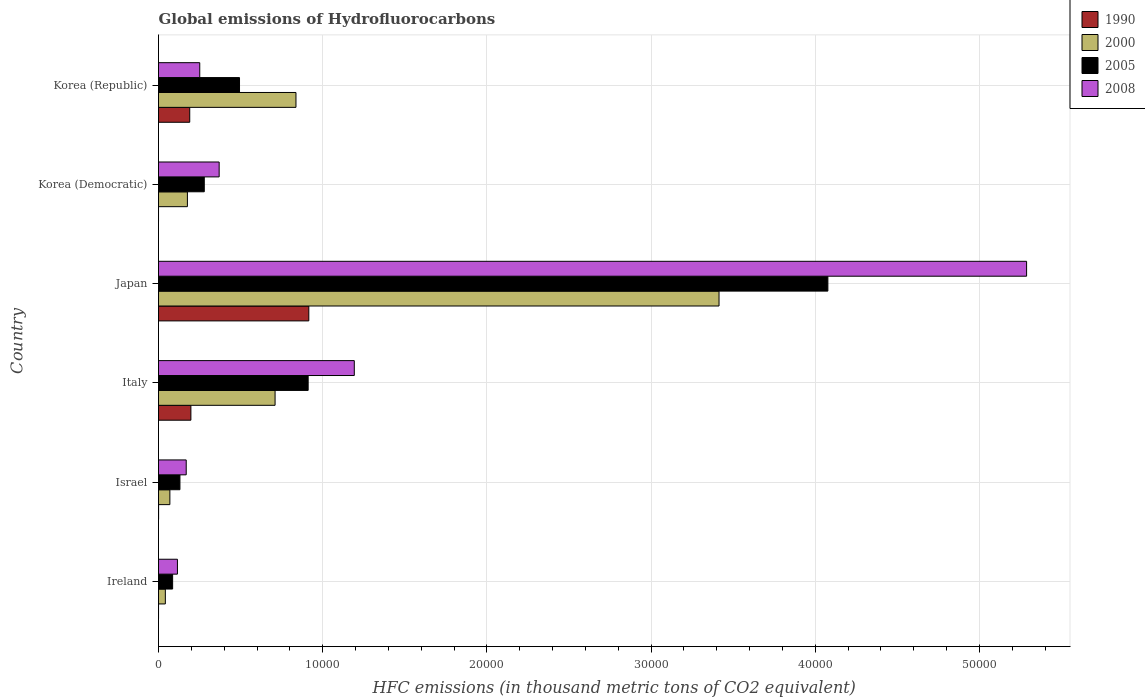How many groups of bars are there?
Provide a succinct answer. 6. Are the number of bars per tick equal to the number of legend labels?
Give a very brief answer. Yes. How many bars are there on the 3rd tick from the top?
Keep it short and to the point. 4. What is the label of the 2nd group of bars from the top?
Keep it short and to the point. Korea (Democratic). What is the global emissions of Hydrofluorocarbons in 2005 in Korea (Democratic)?
Keep it short and to the point. 2787.1. Across all countries, what is the maximum global emissions of Hydrofluorocarbons in 2005?
Your response must be concise. 4.08e+04. Across all countries, what is the minimum global emissions of Hydrofluorocarbons in 2008?
Your response must be concise. 1152.6. In which country was the global emissions of Hydrofluorocarbons in 2005 minimum?
Your answer should be compact. Ireland. What is the total global emissions of Hydrofluorocarbons in 1990 in the graph?
Offer a terse response. 1.30e+04. What is the difference between the global emissions of Hydrofluorocarbons in 2005 in Italy and that in Japan?
Your answer should be compact. -3.17e+04. What is the difference between the global emissions of Hydrofluorocarbons in 2000 in Ireland and the global emissions of Hydrofluorocarbons in 2005 in Italy?
Your answer should be compact. -8698.2. What is the average global emissions of Hydrofluorocarbons in 2000 per country?
Your answer should be compact. 8746.58. What is the difference between the global emissions of Hydrofluorocarbons in 1990 and global emissions of Hydrofluorocarbons in 2008 in Japan?
Your answer should be compact. -4.37e+04. In how many countries, is the global emissions of Hydrofluorocarbons in 1990 greater than 38000 thousand metric tons?
Keep it short and to the point. 0. What is the ratio of the global emissions of Hydrofluorocarbons in 2005 in Ireland to that in Korea (Republic)?
Give a very brief answer. 0.17. What is the difference between the highest and the second highest global emissions of Hydrofluorocarbons in 2008?
Your answer should be very brief. 4.09e+04. What is the difference between the highest and the lowest global emissions of Hydrofluorocarbons in 2000?
Your answer should be very brief. 3.37e+04. Is the sum of the global emissions of Hydrofluorocarbons in 2005 in Ireland and Italy greater than the maximum global emissions of Hydrofluorocarbons in 1990 across all countries?
Offer a very short reply. Yes. Is it the case that in every country, the sum of the global emissions of Hydrofluorocarbons in 2008 and global emissions of Hydrofluorocarbons in 1990 is greater than the global emissions of Hydrofluorocarbons in 2005?
Offer a very short reply. No. How many bars are there?
Make the answer very short. 24. Are all the bars in the graph horizontal?
Offer a very short reply. Yes. Does the graph contain any zero values?
Offer a terse response. No. Where does the legend appear in the graph?
Offer a very short reply. Top right. How many legend labels are there?
Make the answer very short. 4. What is the title of the graph?
Offer a terse response. Global emissions of Hydrofluorocarbons. Does "1993" appear as one of the legend labels in the graph?
Your answer should be very brief. No. What is the label or title of the X-axis?
Provide a succinct answer. HFC emissions (in thousand metric tons of CO2 equivalent). What is the HFC emissions (in thousand metric tons of CO2 equivalent) of 1990 in Ireland?
Ensure brevity in your answer.  1.2. What is the HFC emissions (in thousand metric tons of CO2 equivalent) of 2000 in Ireland?
Provide a succinct answer. 416.3. What is the HFC emissions (in thousand metric tons of CO2 equivalent) of 2005 in Ireland?
Ensure brevity in your answer.  859.7. What is the HFC emissions (in thousand metric tons of CO2 equivalent) in 2008 in Ireland?
Provide a short and direct response. 1152.6. What is the HFC emissions (in thousand metric tons of CO2 equivalent) in 2000 in Israel?
Give a very brief answer. 691.9. What is the HFC emissions (in thousand metric tons of CO2 equivalent) in 2005 in Israel?
Your answer should be very brief. 1305. What is the HFC emissions (in thousand metric tons of CO2 equivalent) of 2008 in Israel?
Provide a short and direct response. 1687.8. What is the HFC emissions (in thousand metric tons of CO2 equivalent) in 1990 in Italy?
Provide a short and direct response. 1972.2. What is the HFC emissions (in thousand metric tons of CO2 equivalent) in 2000 in Italy?
Keep it short and to the point. 7099.5. What is the HFC emissions (in thousand metric tons of CO2 equivalent) of 2005 in Italy?
Offer a very short reply. 9114.5. What is the HFC emissions (in thousand metric tons of CO2 equivalent) of 2008 in Italy?
Provide a short and direct response. 1.19e+04. What is the HFC emissions (in thousand metric tons of CO2 equivalent) in 1990 in Japan?
Provide a short and direct response. 9154.3. What is the HFC emissions (in thousand metric tons of CO2 equivalent) of 2000 in Japan?
Your answer should be compact. 3.41e+04. What is the HFC emissions (in thousand metric tons of CO2 equivalent) of 2005 in Japan?
Make the answer very short. 4.08e+04. What is the HFC emissions (in thousand metric tons of CO2 equivalent) in 2008 in Japan?
Your answer should be very brief. 5.29e+04. What is the HFC emissions (in thousand metric tons of CO2 equivalent) in 1990 in Korea (Democratic)?
Offer a very short reply. 0.2. What is the HFC emissions (in thousand metric tons of CO2 equivalent) of 2000 in Korea (Democratic)?
Your response must be concise. 1760.1. What is the HFC emissions (in thousand metric tons of CO2 equivalent) of 2005 in Korea (Democratic)?
Provide a succinct answer. 2787.1. What is the HFC emissions (in thousand metric tons of CO2 equivalent) of 2008 in Korea (Democratic)?
Keep it short and to the point. 3693.8. What is the HFC emissions (in thousand metric tons of CO2 equivalent) of 1990 in Korea (Republic)?
Give a very brief answer. 1901.7. What is the HFC emissions (in thousand metric tons of CO2 equivalent) of 2000 in Korea (Republic)?
Your answer should be very brief. 8371.9. What is the HFC emissions (in thousand metric tons of CO2 equivalent) of 2005 in Korea (Republic)?
Your response must be concise. 4933.9. What is the HFC emissions (in thousand metric tons of CO2 equivalent) in 2008 in Korea (Republic)?
Provide a short and direct response. 2511.2. Across all countries, what is the maximum HFC emissions (in thousand metric tons of CO2 equivalent) in 1990?
Keep it short and to the point. 9154.3. Across all countries, what is the maximum HFC emissions (in thousand metric tons of CO2 equivalent) in 2000?
Provide a succinct answer. 3.41e+04. Across all countries, what is the maximum HFC emissions (in thousand metric tons of CO2 equivalent) of 2005?
Ensure brevity in your answer.  4.08e+04. Across all countries, what is the maximum HFC emissions (in thousand metric tons of CO2 equivalent) of 2008?
Keep it short and to the point. 5.29e+04. Across all countries, what is the minimum HFC emissions (in thousand metric tons of CO2 equivalent) of 2000?
Provide a succinct answer. 416.3. Across all countries, what is the minimum HFC emissions (in thousand metric tons of CO2 equivalent) of 2005?
Ensure brevity in your answer.  859.7. Across all countries, what is the minimum HFC emissions (in thousand metric tons of CO2 equivalent) of 2008?
Provide a succinct answer. 1152.6. What is the total HFC emissions (in thousand metric tons of CO2 equivalent) of 1990 in the graph?
Ensure brevity in your answer.  1.30e+04. What is the total HFC emissions (in thousand metric tons of CO2 equivalent) in 2000 in the graph?
Your answer should be compact. 5.25e+04. What is the total HFC emissions (in thousand metric tons of CO2 equivalent) of 2005 in the graph?
Provide a succinct answer. 5.98e+04. What is the total HFC emissions (in thousand metric tons of CO2 equivalent) in 2008 in the graph?
Offer a very short reply. 7.38e+04. What is the difference between the HFC emissions (in thousand metric tons of CO2 equivalent) of 2000 in Ireland and that in Israel?
Make the answer very short. -275.6. What is the difference between the HFC emissions (in thousand metric tons of CO2 equivalent) of 2005 in Ireland and that in Israel?
Your answer should be very brief. -445.3. What is the difference between the HFC emissions (in thousand metric tons of CO2 equivalent) of 2008 in Ireland and that in Israel?
Make the answer very short. -535.2. What is the difference between the HFC emissions (in thousand metric tons of CO2 equivalent) of 1990 in Ireland and that in Italy?
Provide a short and direct response. -1971. What is the difference between the HFC emissions (in thousand metric tons of CO2 equivalent) of 2000 in Ireland and that in Italy?
Your answer should be very brief. -6683.2. What is the difference between the HFC emissions (in thousand metric tons of CO2 equivalent) in 2005 in Ireland and that in Italy?
Your response must be concise. -8254.8. What is the difference between the HFC emissions (in thousand metric tons of CO2 equivalent) in 2008 in Ireland and that in Italy?
Offer a terse response. -1.08e+04. What is the difference between the HFC emissions (in thousand metric tons of CO2 equivalent) in 1990 in Ireland and that in Japan?
Your response must be concise. -9153.1. What is the difference between the HFC emissions (in thousand metric tons of CO2 equivalent) in 2000 in Ireland and that in Japan?
Your response must be concise. -3.37e+04. What is the difference between the HFC emissions (in thousand metric tons of CO2 equivalent) in 2005 in Ireland and that in Japan?
Keep it short and to the point. -3.99e+04. What is the difference between the HFC emissions (in thousand metric tons of CO2 equivalent) in 2008 in Ireland and that in Japan?
Give a very brief answer. -5.17e+04. What is the difference between the HFC emissions (in thousand metric tons of CO2 equivalent) of 2000 in Ireland and that in Korea (Democratic)?
Your answer should be very brief. -1343.8. What is the difference between the HFC emissions (in thousand metric tons of CO2 equivalent) of 2005 in Ireland and that in Korea (Democratic)?
Provide a succinct answer. -1927.4. What is the difference between the HFC emissions (in thousand metric tons of CO2 equivalent) of 2008 in Ireland and that in Korea (Democratic)?
Keep it short and to the point. -2541.2. What is the difference between the HFC emissions (in thousand metric tons of CO2 equivalent) in 1990 in Ireland and that in Korea (Republic)?
Ensure brevity in your answer.  -1900.5. What is the difference between the HFC emissions (in thousand metric tons of CO2 equivalent) in 2000 in Ireland and that in Korea (Republic)?
Your response must be concise. -7955.6. What is the difference between the HFC emissions (in thousand metric tons of CO2 equivalent) in 2005 in Ireland and that in Korea (Republic)?
Your answer should be compact. -4074.2. What is the difference between the HFC emissions (in thousand metric tons of CO2 equivalent) in 2008 in Ireland and that in Korea (Republic)?
Give a very brief answer. -1358.6. What is the difference between the HFC emissions (in thousand metric tons of CO2 equivalent) of 1990 in Israel and that in Italy?
Offer a very short reply. -1967.6. What is the difference between the HFC emissions (in thousand metric tons of CO2 equivalent) in 2000 in Israel and that in Italy?
Give a very brief answer. -6407.6. What is the difference between the HFC emissions (in thousand metric tons of CO2 equivalent) of 2005 in Israel and that in Italy?
Keep it short and to the point. -7809.5. What is the difference between the HFC emissions (in thousand metric tons of CO2 equivalent) of 2008 in Israel and that in Italy?
Keep it short and to the point. -1.02e+04. What is the difference between the HFC emissions (in thousand metric tons of CO2 equivalent) of 1990 in Israel and that in Japan?
Your answer should be compact. -9149.7. What is the difference between the HFC emissions (in thousand metric tons of CO2 equivalent) of 2000 in Israel and that in Japan?
Your answer should be very brief. -3.34e+04. What is the difference between the HFC emissions (in thousand metric tons of CO2 equivalent) of 2005 in Israel and that in Japan?
Give a very brief answer. -3.95e+04. What is the difference between the HFC emissions (in thousand metric tons of CO2 equivalent) of 2008 in Israel and that in Japan?
Keep it short and to the point. -5.12e+04. What is the difference between the HFC emissions (in thousand metric tons of CO2 equivalent) in 2000 in Israel and that in Korea (Democratic)?
Your answer should be very brief. -1068.2. What is the difference between the HFC emissions (in thousand metric tons of CO2 equivalent) of 2005 in Israel and that in Korea (Democratic)?
Keep it short and to the point. -1482.1. What is the difference between the HFC emissions (in thousand metric tons of CO2 equivalent) of 2008 in Israel and that in Korea (Democratic)?
Make the answer very short. -2006. What is the difference between the HFC emissions (in thousand metric tons of CO2 equivalent) of 1990 in Israel and that in Korea (Republic)?
Your answer should be compact. -1897.1. What is the difference between the HFC emissions (in thousand metric tons of CO2 equivalent) of 2000 in Israel and that in Korea (Republic)?
Offer a very short reply. -7680. What is the difference between the HFC emissions (in thousand metric tons of CO2 equivalent) in 2005 in Israel and that in Korea (Republic)?
Give a very brief answer. -3628.9. What is the difference between the HFC emissions (in thousand metric tons of CO2 equivalent) in 2008 in Israel and that in Korea (Republic)?
Your answer should be very brief. -823.4. What is the difference between the HFC emissions (in thousand metric tons of CO2 equivalent) in 1990 in Italy and that in Japan?
Provide a short and direct response. -7182.1. What is the difference between the HFC emissions (in thousand metric tons of CO2 equivalent) in 2000 in Italy and that in Japan?
Provide a short and direct response. -2.70e+04. What is the difference between the HFC emissions (in thousand metric tons of CO2 equivalent) in 2005 in Italy and that in Japan?
Ensure brevity in your answer.  -3.17e+04. What is the difference between the HFC emissions (in thousand metric tons of CO2 equivalent) in 2008 in Italy and that in Japan?
Offer a terse response. -4.09e+04. What is the difference between the HFC emissions (in thousand metric tons of CO2 equivalent) in 1990 in Italy and that in Korea (Democratic)?
Provide a short and direct response. 1972. What is the difference between the HFC emissions (in thousand metric tons of CO2 equivalent) of 2000 in Italy and that in Korea (Democratic)?
Provide a short and direct response. 5339.4. What is the difference between the HFC emissions (in thousand metric tons of CO2 equivalent) of 2005 in Italy and that in Korea (Democratic)?
Your answer should be compact. 6327.4. What is the difference between the HFC emissions (in thousand metric tons of CO2 equivalent) of 2008 in Italy and that in Korea (Democratic)?
Offer a very short reply. 8230.7. What is the difference between the HFC emissions (in thousand metric tons of CO2 equivalent) in 1990 in Italy and that in Korea (Republic)?
Keep it short and to the point. 70.5. What is the difference between the HFC emissions (in thousand metric tons of CO2 equivalent) in 2000 in Italy and that in Korea (Republic)?
Your response must be concise. -1272.4. What is the difference between the HFC emissions (in thousand metric tons of CO2 equivalent) in 2005 in Italy and that in Korea (Republic)?
Offer a very short reply. 4180.6. What is the difference between the HFC emissions (in thousand metric tons of CO2 equivalent) in 2008 in Italy and that in Korea (Republic)?
Your answer should be compact. 9413.3. What is the difference between the HFC emissions (in thousand metric tons of CO2 equivalent) in 1990 in Japan and that in Korea (Democratic)?
Provide a short and direct response. 9154.1. What is the difference between the HFC emissions (in thousand metric tons of CO2 equivalent) in 2000 in Japan and that in Korea (Democratic)?
Give a very brief answer. 3.24e+04. What is the difference between the HFC emissions (in thousand metric tons of CO2 equivalent) in 2005 in Japan and that in Korea (Democratic)?
Offer a terse response. 3.80e+04. What is the difference between the HFC emissions (in thousand metric tons of CO2 equivalent) in 2008 in Japan and that in Korea (Democratic)?
Ensure brevity in your answer.  4.92e+04. What is the difference between the HFC emissions (in thousand metric tons of CO2 equivalent) of 1990 in Japan and that in Korea (Republic)?
Your answer should be very brief. 7252.6. What is the difference between the HFC emissions (in thousand metric tons of CO2 equivalent) of 2000 in Japan and that in Korea (Republic)?
Your response must be concise. 2.58e+04. What is the difference between the HFC emissions (in thousand metric tons of CO2 equivalent) in 2005 in Japan and that in Korea (Republic)?
Provide a succinct answer. 3.58e+04. What is the difference between the HFC emissions (in thousand metric tons of CO2 equivalent) in 2008 in Japan and that in Korea (Republic)?
Provide a succinct answer. 5.04e+04. What is the difference between the HFC emissions (in thousand metric tons of CO2 equivalent) in 1990 in Korea (Democratic) and that in Korea (Republic)?
Provide a short and direct response. -1901.5. What is the difference between the HFC emissions (in thousand metric tons of CO2 equivalent) of 2000 in Korea (Democratic) and that in Korea (Republic)?
Keep it short and to the point. -6611.8. What is the difference between the HFC emissions (in thousand metric tons of CO2 equivalent) in 2005 in Korea (Democratic) and that in Korea (Republic)?
Ensure brevity in your answer.  -2146.8. What is the difference between the HFC emissions (in thousand metric tons of CO2 equivalent) of 2008 in Korea (Democratic) and that in Korea (Republic)?
Offer a terse response. 1182.6. What is the difference between the HFC emissions (in thousand metric tons of CO2 equivalent) in 1990 in Ireland and the HFC emissions (in thousand metric tons of CO2 equivalent) in 2000 in Israel?
Offer a terse response. -690.7. What is the difference between the HFC emissions (in thousand metric tons of CO2 equivalent) in 1990 in Ireland and the HFC emissions (in thousand metric tons of CO2 equivalent) in 2005 in Israel?
Offer a very short reply. -1303.8. What is the difference between the HFC emissions (in thousand metric tons of CO2 equivalent) in 1990 in Ireland and the HFC emissions (in thousand metric tons of CO2 equivalent) in 2008 in Israel?
Your answer should be compact. -1686.6. What is the difference between the HFC emissions (in thousand metric tons of CO2 equivalent) of 2000 in Ireland and the HFC emissions (in thousand metric tons of CO2 equivalent) of 2005 in Israel?
Make the answer very short. -888.7. What is the difference between the HFC emissions (in thousand metric tons of CO2 equivalent) in 2000 in Ireland and the HFC emissions (in thousand metric tons of CO2 equivalent) in 2008 in Israel?
Keep it short and to the point. -1271.5. What is the difference between the HFC emissions (in thousand metric tons of CO2 equivalent) of 2005 in Ireland and the HFC emissions (in thousand metric tons of CO2 equivalent) of 2008 in Israel?
Your answer should be compact. -828.1. What is the difference between the HFC emissions (in thousand metric tons of CO2 equivalent) of 1990 in Ireland and the HFC emissions (in thousand metric tons of CO2 equivalent) of 2000 in Italy?
Provide a short and direct response. -7098.3. What is the difference between the HFC emissions (in thousand metric tons of CO2 equivalent) of 1990 in Ireland and the HFC emissions (in thousand metric tons of CO2 equivalent) of 2005 in Italy?
Give a very brief answer. -9113.3. What is the difference between the HFC emissions (in thousand metric tons of CO2 equivalent) in 1990 in Ireland and the HFC emissions (in thousand metric tons of CO2 equivalent) in 2008 in Italy?
Provide a succinct answer. -1.19e+04. What is the difference between the HFC emissions (in thousand metric tons of CO2 equivalent) of 2000 in Ireland and the HFC emissions (in thousand metric tons of CO2 equivalent) of 2005 in Italy?
Your answer should be compact. -8698.2. What is the difference between the HFC emissions (in thousand metric tons of CO2 equivalent) in 2000 in Ireland and the HFC emissions (in thousand metric tons of CO2 equivalent) in 2008 in Italy?
Provide a succinct answer. -1.15e+04. What is the difference between the HFC emissions (in thousand metric tons of CO2 equivalent) of 2005 in Ireland and the HFC emissions (in thousand metric tons of CO2 equivalent) of 2008 in Italy?
Make the answer very short. -1.11e+04. What is the difference between the HFC emissions (in thousand metric tons of CO2 equivalent) of 1990 in Ireland and the HFC emissions (in thousand metric tons of CO2 equivalent) of 2000 in Japan?
Your answer should be very brief. -3.41e+04. What is the difference between the HFC emissions (in thousand metric tons of CO2 equivalent) in 1990 in Ireland and the HFC emissions (in thousand metric tons of CO2 equivalent) in 2005 in Japan?
Keep it short and to the point. -4.08e+04. What is the difference between the HFC emissions (in thousand metric tons of CO2 equivalent) of 1990 in Ireland and the HFC emissions (in thousand metric tons of CO2 equivalent) of 2008 in Japan?
Make the answer very short. -5.29e+04. What is the difference between the HFC emissions (in thousand metric tons of CO2 equivalent) in 2000 in Ireland and the HFC emissions (in thousand metric tons of CO2 equivalent) in 2005 in Japan?
Provide a short and direct response. -4.04e+04. What is the difference between the HFC emissions (in thousand metric tons of CO2 equivalent) of 2000 in Ireland and the HFC emissions (in thousand metric tons of CO2 equivalent) of 2008 in Japan?
Give a very brief answer. -5.25e+04. What is the difference between the HFC emissions (in thousand metric tons of CO2 equivalent) of 2005 in Ireland and the HFC emissions (in thousand metric tons of CO2 equivalent) of 2008 in Japan?
Your response must be concise. -5.20e+04. What is the difference between the HFC emissions (in thousand metric tons of CO2 equivalent) in 1990 in Ireland and the HFC emissions (in thousand metric tons of CO2 equivalent) in 2000 in Korea (Democratic)?
Keep it short and to the point. -1758.9. What is the difference between the HFC emissions (in thousand metric tons of CO2 equivalent) of 1990 in Ireland and the HFC emissions (in thousand metric tons of CO2 equivalent) of 2005 in Korea (Democratic)?
Make the answer very short. -2785.9. What is the difference between the HFC emissions (in thousand metric tons of CO2 equivalent) in 1990 in Ireland and the HFC emissions (in thousand metric tons of CO2 equivalent) in 2008 in Korea (Democratic)?
Make the answer very short. -3692.6. What is the difference between the HFC emissions (in thousand metric tons of CO2 equivalent) of 2000 in Ireland and the HFC emissions (in thousand metric tons of CO2 equivalent) of 2005 in Korea (Democratic)?
Your response must be concise. -2370.8. What is the difference between the HFC emissions (in thousand metric tons of CO2 equivalent) in 2000 in Ireland and the HFC emissions (in thousand metric tons of CO2 equivalent) in 2008 in Korea (Democratic)?
Keep it short and to the point. -3277.5. What is the difference between the HFC emissions (in thousand metric tons of CO2 equivalent) of 2005 in Ireland and the HFC emissions (in thousand metric tons of CO2 equivalent) of 2008 in Korea (Democratic)?
Ensure brevity in your answer.  -2834.1. What is the difference between the HFC emissions (in thousand metric tons of CO2 equivalent) in 1990 in Ireland and the HFC emissions (in thousand metric tons of CO2 equivalent) in 2000 in Korea (Republic)?
Your answer should be very brief. -8370.7. What is the difference between the HFC emissions (in thousand metric tons of CO2 equivalent) of 1990 in Ireland and the HFC emissions (in thousand metric tons of CO2 equivalent) of 2005 in Korea (Republic)?
Your answer should be compact. -4932.7. What is the difference between the HFC emissions (in thousand metric tons of CO2 equivalent) in 1990 in Ireland and the HFC emissions (in thousand metric tons of CO2 equivalent) in 2008 in Korea (Republic)?
Your answer should be compact. -2510. What is the difference between the HFC emissions (in thousand metric tons of CO2 equivalent) in 2000 in Ireland and the HFC emissions (in thousand metric tons of CO2 equivalent) in 2005 in Korea (Republic)?
Your answer should be very brief. -4517.6. What is the difference between the HFC emissions (in thousand metric tons of CO2 equivalent) in 2000 in Ireland and the HFC emissions (in thousand metric tons of CO2 equivalent) in 2008 in Korea (Republic)?
Ensure brevity in your answer.  -2094.9. What is the difference between the HFC emissions (in thousand metric tons of CO2 equivalent) in 2005 in Ireland and the HFC emissions (in thousand metric tons of CO2 equivalent) in 2008 in Korea (Republic)?
Give a very brief answer. -1651.5. What is the difference between the HFC emissions (in thousand metric tons of CO2 equivalent) of 1990 in Israel and the HFC emissions (in thousand metric tons of CO2 equivalent) of 2000 in Italy?
Provide a short and direct response. -7094.9. What is the difference between the HFC emissions (in thousand metric tons of CO2 equivalent) in 1990 in Israel and the HFC emissions (in thousand metric tons of CO2 equivalent) in 2005 in Italy?
Offer a terse response. -9109.9. What is the difference between the HFC emissions (in thousand metric tons of CO2 equivalent) in 1990 in Israel and the HFC emissions (in thousand metric tons of CO2 equivalent) in 2008 in Italy?
Your answer should be compact. -1.19e+04. What is the difference between the HFC emissions (in thousand metric tons of CO2 equivalent) of 2000 in Israel and the HFC emissions (in thousand metric tons of CO2 equivalent) of 2005 in Italy?
Keep it short and to the point. -8422.6. What is the difference between the HFC emissions (in thousand metric tons of CO2 equivalent) of 2000 in Israel and the HFC emissions (in thousand metric tons of CO2 equivalent) of 2008 in Italy?
Offer a terse response. -1.12e+04. What is the difference between the HFC emissions (in thousand metric tons of CO2 equivalent) in 2005 in Israel and the HFC emissions (in thousand metric tons of CO2 equivalent) in 2008 in Italy?
Give a very brief answer. -1.06e+04. What is the difference between the HFC emissions (in thousand metric tons of CO2 equivalent) in 1990 in Israel and the HFC emissions (in thousand metric tons of CO2 equivalent) in 2000 in Japan?
Provide a succinct answer. -3.41e+04. What is the difference between the HFC emissions (in thousand metric tons of CO2 equivalent) of 1990 in Israel and the HFC emissions (in thousand metric tons of CO2 equivalent) of 2005 in Japan?
Ensure brevity in your answer.  -4.08e+04. What is the difference between the HFC emissions (in thousand metric tons of CO2 equivalent) of 1990 in Israel and the HFC emissions (in thousand metric tons of CO2 equivalent) of 2008 in Japan?
Make the answer very short. -5.29e+04. What is the difference between the HFC emissions (in thousand metric tons of CO2 equivalent) of 2000 in Israel and the HFC emissions (in thousand metric tons of CO2 equivalent) of 2005 in Japan?
Your response must be concise. -4.01e+04. What is the difference between the HFC emissions (in thousand metric tons of CO2 equivalent) of 2000 in Israel and the HFC emissions (in thousand metric tons of CO2 equivalent) of 2008 in Japan?
Give a very brief answer. -5.22e+04. What is the difference between the HFC emissions (in thousand metric tons of CO2 equivalent) in 2005 in Israel and the HFC emissions (in thousand metric tons of CO2 equivalent) in 2008 in Japan?
Your answer should be compact. -5.16e+04. What is the difference between the HFC emissions (in thousand metric tons of CO2 equivalent) of 1990 in Israel and the HFC emissions (in thousand metric tons of CO2 equivalent) of 2000 in Korea (Democratic)?
Ensure brevity in your answer.  -1755.5. What is the difference between the HFC emissions (in thousand metric tons of CO2 equivalent) in 1990 in Israel and the HFC emissions (in thousand metric tons of CO2 equivalent) in 2005 in Korea (Democratic)?
Your answer should be very brief. -2782.5. What is the difference between the HFC emissions (in thousand metric tons of CO2 equivalent) in 1990 in Israel and the HFC emissions (in thousand metric tons of CO2 equivalent) in 2008 in Korea (Democratic)?
Ensure brevity in your answer.  -3689.2. What is the difference between the HFC emissions (in thousand metric tons of CO2 equivalent) of 2000 in Israel and the HFC emissions (in thousand metric tons of CO2 equivalent) of 2005 in Korea (Democratic)?
Give a very brief answer. -2095.2. What is the difference between the HFC emissions (in thousand metric tons of CO2 equivalent) in 2000 in Israel and the HFC emissions (in thousand metric tons of CO2 equivalent) in 2008 in Korea (Democratic)?
Your answer should be very brief. -3001.9. What is the difference between the HFC emissions (in thousand metric tons of CO2 equivalent) of 2005 in Israel and the HFC emissions (in thousand metric tons of CO2 equivalent) of 2008 in Korea (Democratic)?
Provide a short and direct response. -2388.8. What is the difference between the HFC emissions (in thousand metric tons of CO2 equivalent) in 1990 in Israel and the HFC emissions (in thousand metric tons of CO2 equivalent) in 2000 in Korea (Republic)?
Your response must be concise. -8367.3. What is the difference between the HFC emissions (in thousand metric tons of CO2 equivalent) in 1990 in Israel and the HFC emissions (in thousand metric tons of CO2 equivalent) in 2005 in Korea (Republic)?
Offer a terse response. -4929.3. What is the difference between the HFC emissions (in thousand metric tons of CO2 equivalent) of 1990 in Israel and the HFC emissions (in thousand metric tons of CO2 equivalent) of 2008 in Korea (Republic)?
Ensure brevity in your answer.  -2506.6. What is the difference between the HFC emissions (in thousand metric tons of CO2 equivalent) in 2000 in Israel and the HFC emissions (in thousand metric tons of CO2 equivalent) in 2005 in Korea (Republic)?
Offer a terse response. -4242. What is the difference between the HFC emissions (in thousand metric tons of CO2 equivalent) in 2000 in Israel and the HFC emissions (in thousand metric tons of CO2 equivalent) in 2008 in Korea (Republic)?
Your answer should be very brief. -1819.3. What is the difference between the HFC emissions (in thousand metric tons of CO2 equivalent) of 2005 in Israel and the HFC emissions (in thousand metric tons of CO2 equivalent) of 2008 in Korea (Republic)?
Offer a very short reply. -1206.2. What is the difference between the HFC emissions (in thousand metric tons of CO2 equivalent) of 1990 in Italy and the HFC emissions (in thousand metric tons of CO2 equivalent) of 2000 in Japan?
Give a very brief answer. -3.22e+04. What is the difference between the HFC emissions (in thousand metric tons of CO2 equivalent) in 1990 in Italy and the HFC emissions (in thousand metric tons of CO2 equivalent) in 2005 in Japan?
Offer a very short reply. -3.88e+04. What is the difference between the HFC emissions (in thousand metric tons of CO2 equivalent) of 1990 in Italy and the HFC emissions (in thousand metric tons of CO2 equivalent) of 2008 in Japan?
Your answer should be very brief. -5.09e+04. What is the difference between the HFC emissions (in thousand metric tons of CO2 equivalent) in 2000 in Italy and the HFC emissions (in thousand metric tons of CO2 equivalent) in 2005 in Japan?
Keep it short and to the point. -3.37e+04. What is the difference between the HFC emissions (in thousand metric tons of CO2 equivalent) in 2000 in Italy and the HFC emissions (in thousand metric tons of CO2 equivalent) in 2008 in Japan?
Your answer should be very brief. -4.58e+04. What is the difference between the HFC emissions (in thousand metric tons of CO2 equivalent) in 2005 in Italy and the HFC emissions (in thousand metric tons of CO2 equivalent) in 2008 in Japan?
Make the answer very short. -4.38e+04. What is the difference between the HFC emissions (in thousand metric tons of CO2 equivalent) of 1990 in Italy and the HFC emissions (in thousand metric tons of CO2 equivalent) of 2000 in Korea (Democratic)?
Ensure brevity in your answer.  212.1. What is the difference between the HFC emissions (in thousand metric tons of CO2 equivalent) in 1990 in Italy and the HFC emissions (in thousand metric tons of CO2 equivalent) in 2005 in Korea (Democratic)?
Make the answer very short. -814.9. What is the difference between the HFC emissions (in thousand metric tons of CO2 equivalent) in 1990 in Italy and the HFC emissions (in thousand metric tons of CO2 equivalent) in 2008 in Korea (Democratic)?
Ensure brevity in your answer.  -1721.6. What is the difference between the HFC emissions (in thousand metric tons of CO2 equivalent) in 2000 in Italy and the HFC emissions (in thousand metric tons of CO2 equivalent) in 2005 in Korea (Democratic)?
Keep it short and to the point. 4312.4. What is the difference between the HFC emissions (in thousand metric tons of CO2 equivalent) of 2000 in Italy and the HFC emissions (in thousand metric tons of CO2 equivalent) of 2008 in Korea (Democratic)?
Keep it short and to the point. 3405.7. What is the difference between the HFC emissions (in thousand metric tons of CO2 equivalent) in 2005 in Italy and the HFC emissions (in thousand metric tons of CO2 equivalent) in 2008 in Korea (Democratic)?
Your answer should be very brief. 5420.7. What is the difference between the HFC emissions (in thousand metric tons of CO2 equivalent) of 1990 in Italy and the HFC emissions (in thousand metric tons of CO2 equivalent) of 2000 in Korea (Republic)?
Offer a very short reply. -6399.7. What is the difference between the HFC emissions (in thousand metric tons of CO2 equivalent) in 1990 in Italy and the HFC emissions (in thousand metric tons of CO2 equivalent) in 2005 in Korea (Republic)?
Ensure brevity in your answer.  -2961.7. What is the difference between the HFC emissions (in thousand metric tons of CO2 equivalent) in 1990 in Italy and the HFC emissions (in thousand metric tons of CO2 equivalent) in 2008 in Korea (Republic)?
Provide a succinct answer. -539. What is the difference between the HFC emissions (in thousand metric tons of CO2 equivalent) of 2000 in Italy and the HFC emissions (in thousand metric tons of CO2 equivalent) of 2005 in Korea (Republic)?
Your answer should be compact. 2165.6. What is the difference between the HFC emissions (in thousand metric tons of CO2 equivalent) in 2000 in Italy and the HFC emissions (in thousand metric tons of CO2 equivalent) in 2008 in Korea (Republic)?
Provide a short and direct response. 4588.3. What is the difference between the HFC emissions (in thousand metric tons of CO2 equivalent) of 2005 in Italy and the HFC emissions (in thousand metric tons of CO2 equivalent) of 2008 in Korea (Republic)?
Keep it short and to the point. 6603.3. What is the difference between the HFC emissions (in thousand metric tons of CO2 equivalent) in 1990 in Japan and the HFC emissions (in thousand metric tons of CO2 equivalent) in 2000 in Korea (Democratic)?
Give a very brief answer. 7394.2. What is the difference between the HFC emissions (in thousand metric tons of CO2 equivalent) in 1990 in Japan and the HFC emissions (in thousand metric tons of CO2 equivalent) in 2005 in Korea (Democratic)?
Your response must be concise. 6367.2. What is the difference between the HFC emissions (in thousand metric tons of CO2 equivalent) of 1990 in Japan and the HFC emissions (in thousand metric tons of CO2 equivalent) of 2008 in Korea (Democratic)?
Provide a short and direct response. 5460.5. What is the difference between the HFC emissions (in thousand metric tons of CO2 equivalent) of 2000 in Japan and the HFC emissions (in thousand metric tons of CO2 equivalent) of 2005 in Korea (Democratic)?
Give a very brief answer. 3.14e+04. What is the difference between the HFC emissions (in thousand metric tons of CO2 equivalent) of 2000 in Japan and the HFC emissions (in thousand metric tons of CO2 equivalent) of 2008 in Korea (Democratic)?
Offer a terse response. 3.04e+04. What is the difference between the HFC emissions (in thousand metric tons of CO2 equivalent) in 2005 in Japan and the HFC emissions (in thousand metric tons of CO2 equivalent) in 2008 in Korea (Democratic)?
Provide a succinct answer. 3.71e+04. What is the difference between the HFC emissions (in thousand metric tons of CO2 equivalent) of 1990 in Japan and the HFC emissions (in thousand metric tons of CO2 equivalent) of 2000 in Korea (Republic)?
Make the answer very short. 782.4. What is the difference between the HFC emissions (in thousand metric tons of CO2 equivalent) of 1990 in Japan and the HFC emissions (in thousand metric tons of CO2 equivalent) of 2005 in Korea (Republic)?
Your answer should be very brief. 4220.4. What is the difference between the HFC emissions (in thousand metric tons of CO2 equivalent) of 1990 in Japan and the HFC emissions (in thousand metric tons of CO2 equivalent) of 2008 in Korea (Republic)?
Offer a very short reply. 6643.1. What is the difference between the HFC emissions (in thousand metric tons of CO2 equivalent) in 2000 in Japan and the HFC emissions (in thousand metric tons of CO2 equivalent) in 2005 in Korea (Republic)?
Offer a very short reply. 2.92e+04. What is the difference between the HFC emissions (in thousand metric tons of CO2 equivalent) in 2000 in Japan and the HFC emissions (in thousand metric tons of CO2 equivalent) in 2008 in Korea (Republic)?
Provide a succinct answer. 3.16e+04. What is the difference between the HFC emissions (in thousand metric tons of CO2 equivalent) in 2005 in Japan and the HFC emissions (in thousand metric tons of CO2 equivalent) in 2008 in Korea (Republic)?
Your response must be concise. 3.83e+04. What is the difference between the HFC emissions (in thousand metric tons of CO2 equivalent) of 1990 in Korea (Democratic) and the HFC emissions (in thousand metric tons of CO2 equivalent) of 2000 in Korea (Republic)?
Provide a succinct answer. -8371.7. What is the difference between the HFC emissions (in thousand metric tons of CO2 equivalent) of 1990 in Korea (Democratic) and the HFC emissions (in thousand metric tons of CO2 equivalent) of 2005 in Korea (Republic)?
Keep it short and to the point. -4933.7. What is the difference between the HFC emissions (in thousand metric tons of CO2 equivalent) of 1990 in Korea (Democratic) and the HFC emissions (in thousand metric tons of CO2 equivalent) of 2008 in Korea (Republic)?
Keep it short and to the point. -2511. What is the difference between the HFC emissions (in thousand metric tons of CO2 equivalent) in 2000 in Korea (Democratic) and the HFC emissions (in thousand metric tons of CO2 equivalent) in 2005 in Korea (Republic)?
Give a very brief answer. -3173.8. What is the difference between the HFC emissions (in thousand metric tons of CO2 equivalent) in 2000 in Korea (Democratic) and the HFC emissions (in thousand metric tons of CO2 equivalent) in 2008 in Korea (Republic)?
Provide a short and direct response. -751.1. What is the difference between the HFC emissions (in thousand metric tons of CO2 equivalent) in 2005 in Korea (Democratic) and the HFC emissions (in thousand metric tons of CO2 equivalent) in 2008 in Korea (Republic)?
Ensure brevity in your answer.  275.9. What is the average HFC emissions (in thousand metric tons of CO2 equivalent) of 1990 per country?
Make the answer very short. 2172.37. What is the average HFC emissions (in thousand metric tons of CO2 equivalent) of 2000 per country?
Your answer should be compact. 8746.58. What is the average HFC emissions (in thousand metric tons of CO2 equivalent) in 2005 per country?
Ensure brevity in your answer.  9961.45. What is the average HFC emissions (in thousand metric tons of CO2 equivalent) of 2008 per country?
Give a very brief answer. 1.23e+04. What is the difference between the HFC emissions (in thousand metric tons of CO2 equivalent) of 1990 and HFC emissions (in thousand metric tons of CO2 equivalent) of 2000 in Ireland?
Your answer should be very brief. -415.1. What is the difference between the HFC emissions (in thousand metric tons of CO2 equivalent) of 1990 and HFC emissions (in thousand metric tons of CO2 equivalent) of 2005 in Ireland?
Provide a succinct answer. -858.5. What is the difference between the HFC emissions (in thousand metric tons of CO2 equivalent) in 1990 and HFC emissions (in thousand metric tons of CO2 equivalent) in 2008 in Ireland?
Offer a very short reply. -1151.4. What is the difference between the HFC emissions (in thousand metric tons of CO2 equivalent) in 2000 and HFC emissions (in thousand metric tons of CO2 equivalent) in 2005 in Ireland?
Provide a short and direct response. -443.4. What is the difference between the HFC emissions (in thousand metric tons of CO2 equivalent) of 2000 and HFC emissions (in thousand metric tons of CO2 equivalent) of 2008 in Ireland?
Ensure brevity in your answer.  -736.3. What is the difference between the HFC emissions (in thousand metric tons of CO2 equivalent) in 2005 and HFC emissions (in thousand metric tons of CO2 equivalent) in 2008 in Ireland?
Your response must be concise. -292.9. What is the difference between the HFC emissions (in thousand metric tons of CO2 equivalent) of 1990 and HFC emissions (in thousand metric tons of CO2 equivalent) of 2000 in Israel?
Offer a terse response. -687.3. What is the difference between the HFC emissions (in thousand metric tons of CO2 equivalent) in 1990 and HFC emissions (in thousand metric tons of CO2 equivalent) in 2005 in Israel?
Give a very brief answer. -1300.4. What is the difference between the HFC emissions (in thousand metric tons of CO2 equivalent) of 1990 and HFC emissions (in thousand metric tons of CO2 equivalent) of 2008 in Israel?
Keep it short and to the point. -1683.2. What is the difference between the HFC emissions (in thousand metric tons of CO2 equivalent) in 2000 and HFC emissions (in thousand metric tons of CO2 equivalent) in 2005 in Israel?
Provide a short and direct response. -613.1. What is the difference between the HFC emissions (in thousand metric tons of CO2 equivalent) in 2000 and HFC emissions (in thousand metric tons of CO2 equivalent) in 2008 in Israel?
Provide a short and direct response. -995.9. What is the difference between the HFC emissions (in thousand metric tons of CO2 equivalent) of 2005 and HFC emissions (in thousand metric tons of CO2 equivalent) of 2008 in Israel?
Your answer should be compact. -382.8. What is the difference between the HFC emissions (in thousand metric tons of CO2 equivalent) of 1990 and HFC emissions (in thousand metric tons of CO2 equivalent) of 2000 in Italy?
Offer a terse response. -5127.3. What is the difference between the HFC emissions (in thousand metric tons of CO2 equivalent) of 1990 and HFC emissions (in thousand metric tons of CO2 equivalent) of 2005 in Italy?
Give a very brief answer. -7142.3. What is the difference between the HFC emissions (in thousand metric tons of CO2 equivalent) of 1990 and HFC emissions (in thousand metric tons of CO2 equivalent) of 2008 in Italy?
Keep it short and to the point. -9952.3. What is the difference between the HFC emissions (in thousand metric tons of CO2 equivalent) of 2000 and HFC emissions (in thousand metric tons of CO2 equivalent) of 2005 in Italy?
Offer a very short reply. -2015. What is the difference between the HFC emissions (in thousand metric tons of CO2 equivalent) of 2000 and HFC emissions (in thousand metric tons of CO2 equivalent) of 2008 in Italy?
Provide a short and direct response. -4825. What is the difference between the HFC emissions (in thousand metric tons of CO2 equivalent) in 2005 and HFC emissions (in thousand metric tons of CO2 equivalent) in 2008 in Italy?
Ensure brevity in your answer.  -2810. What is the difference between the HFC emissions (in thousand metric tons of CO2 equivalent) in 1990 and HFC emissions (in thousand metric tons of CO2 equivalent) in 2000 in Japan?
Offer a very short reply. -2.50e+04. What is the difference between the HFC emissions (in thousand metric tons of CO2 equivalent) of 1990 and HFC emissions (in thousand metric tons of CO2 equivalent) of 2005 in Japan?
Ensure brevity in your answer.  -3.16e+04. What is the difference between the HFC emissions (in thousand metric tons of CO2 equivalent) of 1990 and HFC emissions (in thousand metric tons of CO2 equivalent) of 2008 in Japan?
Your response must be concise. -4.37e+04. What is the difference between the HFC emissions (in thousand metric tons of CO2 equivalent) of 2000 and HFC emissions (in thousand metric tons of CO2 equivalent) of 2005 in Japan?
Provide a short and direct response. -6628.7. What is the difference between the HFC emissions (in thousand metric tons of CO2 equivalent) in 2000 and HFC emissions (in thousand metric tons of CO2 equivalent) in 2008 in Japan?
Offer a terse response. -1.87e+04. What is the difference between the HFC emissions (in thousand metric tons of CO2 equivalent) of 2005 and HFC emissions (in thousand metric tons of CO2 equivalent) of 2008 in Japan?
Provide a short and direct response. -1.21e+04. What is the difference between the HFC emissions (in thousand metric tons of CO2 equivalent) of 1990 and HFC emissions (in thousand metric tons of CO2 equivalent) of 2000 in Korea (Democratic)?
Offer a terse response. -1759.9. What is the difference between the HFC emissions (in thousand metric tons of CO2 equivalent) in 1990 and HFC emissions (in thousand metric tons of CO2 equivalent) in 2005 in Korea (Democratic)?
Offer a terse response. -2786.9. What is the difference between the HFC emissions (in thousand metric tons of CO2 equivalent) of 1990 and HFC emissions (in thousand metric tons of CO2 equivalent) of 2008 in Korea (Democratic)?
Provide a short and direct response. -3693.6. What is the difference between the HFC emissions (in thousand metric tons of CO2 equivalent) in 2000 and HFC emissions (in thousand metric tons of CO2 equivalent) in 2005 in Korea (Democratic)?
Keep it short and to the point. -1027. What is the difference between the HFC emissions (in thousand metric tons of CO2 equivalent) of 2000 and HFC emissions (in thousand metric tons of CO2 equivalent) of 2008 in Korea (Democratic)?
Your answer should be compact. -1933.7. What is the difference between the HFC emissions (in thousand metric tons of CO2 equivalent) in 2005 and HFC emissions (in thousand metric tons of CO2 equivalent) in 2008 in Korea (Democratic)?
Give a very brief answer. -906.7. What is the difference between the HFC emissions (in thousand metric tons of CO2 equivalent) in 1990 and HFC emissions (in thousand metric tons of CO2 equivalent) in 2000 in Korea (Republic)?
Ensure brevity in your answer.  -6470.2. What is the difference between the HFC emissions (in thousand metric tons of CO2 equivalent) of 1990 and HFC emissions (in thousand metric tons of CO2 equivalent) of 2005 in Korea (Republic)?
Your answer should be very brief. -3032.2. What is the difference between the HFC emissions (in thousand metric tons of CO2 equivalent) of 1990 and HFC emissions (in thousand metric tons of CO2 equivalent) of 2008 in Korea (Republic)?
Your answer should be compact. -609.5. What is the difference between the HFC emissions (in thousand metric tons of CO2 equivalent) of 2000 and HFC emissions (in thousand metric tons of CO2 equivalent) of 2005 in Korea (Republic)?
Your answer should be compact. 3438. What is the difference between the HFC emissions (in thousand metric tons of CO2 equivalent) in 2000 and HFC emissions (in thousand metric tons of CO2 equivalent) in 2008 in Korea (Republic)?
Your answer should be compact. 5860.7. What is the difference between the HFC emissions (in thousand metric tons of CO2 equivalent) of 2005 and HFC emissions (in thousand metric tons of CO2 equivalent) of 2008 in Korea (Republic)?
Your response must be concise. 2422.7. What is the ratio of the HFC emissions (in thousand metric tons of CO2 equivalent) of 1990 in Ireland to that in Israel?
Make the answer very short. 0.26. What is the ratio of the HFC emissions (in thousand metric tons of CO2 equivalent) in 2000 in Ireland to that in Israel?
Your response must be concise. 0.6. What is the ratio of the HFC emissions (in thousand metric tons of CO2 equivalent) of 2005 in Ireland to that in Israel?
Provide a succinct answer. 0.66. What is the ratio of the HFC emissions (in thousand metric tons of CO2 equivalent) of 2008 in Ireland to that in Israel?
Keep it short and to the point. 0.68. What is the ratio of the HFC emissions (in thousand metric tons of CO2 equivalent) in 1990 in Ireland to that in Italy?
Give a very brief answer. 0. What is the ratio of the HFC emissions (in thousand metric tons of CO2 equivalent) in 2000 in Ireland to that in Italy?
Provide a succinct answer. 0.06. What is the ratio of the HFC emissions (in thousand metric tons of CO2 equivalent) in 2005 in Ireland to that in Italy?
Make the answer very short. 0.09. What is the ratio of the HFC emissions (in thousand metric tons of CO2 equivalent) in 2008 in Ireland to that in Italy?
Your answer should be very brief. 0.1. What is the ratio of the HFC emissions (in thousand metric tons of CO2 equivalent) in 2000 in Ireland to that in Japan?
Give a very brief answer. 0.01. What is the ratio of the HFC emissions (in thousand metric tons of CO2 equivalent) in 2005 in Ireland to that in Japan?
Your answer should be compact. 0.02. What is the ratio of the HFC emissions (in thousand metric tons of CO2 equivalent) in 2008 in Ireland to that in Japan?
Your answer should be very brief. 0.02. What is the ratio of the HFC emissions (in thousand metric tons of CO2 equivalent) of 2000 in Ireland to that in Korea (Democratic)?
Ensure brevity in your answer.  0.24. What is the ratio of the HFC emissions (in thousand metric tons of CO2 equivalent) of 2005 in Ireland to that in Korea (Democratic)?
Give a very brief answer. 0.31. What is the ratio of the HFC emissions (in thousand metric tons of CO2 equivalent) of 2008 in Ireland to that in Korea (Democratic)?
Provide a succinct answer. 0.31. What is the ratio of the HFC emissions (in thousand metric tons of CO2 equivalent) in 1990 in Ireland to that in Korea (Republic)?
Provide a succinct answer. 0. What is the ratio of the HFC emissions (in thousand metric tons of CO2 equivalent) of 2000 in Ireland to that in Korea (Republic)?
Give a very brief answer. 0.05. What is the ratio of the HFC emissions (in thousand metric tons of CO2 equivalent) in 2005 in Ireland to that in Korea (Republic)?
Keep it short and to the point. 0.17. What is the ratio of the HFC emissions (in thousand metric tons of CO2 equivalent) in 2008 in Ireland to that in Korea (Republic)?
Give a very brief answer. 0.46. What is the ratio of the HFC emissions (in thousand metric tons of CO2 equivalent) of 1990 in Israel to that in Italy?
Your answer should be compact. 0. What is the ratio of the HFC emissions (in thousand metric tons of CO2 equivalent) in 2000 in Israel to that in Italy?
Ensure brevity in your answer.  0.1. What is the ratio of the HFC emissions (in thousand metric tons of CO2 equivalent) of 2005 in Israel to that in Italy?
Keep it short and to the point. 0.14. What is the ratio of the HFC emissions (in thousand metric tons of CO2 equivalent) of 2008 in Israel to that in Italy?
Keep it short and to the point. 0.14. What is the ratio of the HFC emissions (in thousand metric tons of CO2 equivalent) in 2000 in Israel to that in Japan?
Give a very brief answer. 0.02. What is the ratio of the HFC emissions (in thousand metric tons of CO2 equivalent) in 2005 in Israel to that in Japan?
Your answer should be very brief. 0.03. What is the ratio of the HFC emissions (in thousand metric tons of CO2 equivalent) of 2008 in Israel to that in Japan?
Make the answer very short. 0.03. What is the ratio of the HFC emissions (in thousand metric tons of CO2 equivalent) of 1990 in Israel to that in Korea (Democratic)?
Provide a short and direct response. 23. What is the ratio of the HFC emissions (in thousand metric tons of CO2 equivalent) in 2000 in Israel to that in Korea (Democratic)?
Provide a short and direct response. 0.39. What is the ratio of the HFC emissions (in thousand metric tons of CO2 equivalent) of 2005 in Israel to that in Korea (Democratic)?
Offer a terse response. 0.47. What is the ratio of the HFC emissions (in thousand metric tons of CO2 equivalent) in 2008 in Israel to that in Korea (Democratic)?
Provide a succinct answer. 0.46. What is the ratio of the HFC emissions (in thousand metric tons of CO2 equivalent) in 1990 in Israel to that in Korea (Republic)?
Keep it short and to the point. 0. What is the ratio of the HFC emissions (in thousand metric tons of CO2 equivalent) of 2000 in Israel to that in Korea (Republic)?
Make the answer very short. 0.08. What is the ratio of the HFC emissions (in thousand metric tons of CO2 equivalent) of 2005 in Israel to that in Korea (Republic)?
Offer a terse response. 0.26. What is the ratio of the HFC emissions (in thousand metric tons of CO2 equivalent) in 2008 in Israel to that in Korea (Republic)?
Your answer should be compact. 0.67. What is the ratio of the HFC emissions (in thousand metric tons of CO2 equivalent) of 1990 in Italy to that in Japan?
Your answer should be very brief. 0.22. What is the ratio of the HFC emissions (in thousand metric tons of CO2 equivalent) of 2000 in Italy to that in Japan?
Ensure brevity in your answer.  0.21. What is the ratio of the HFC emissions (in thousand metric tons of CO2 equivalent) of 2005 in Italy to that in Japan?
Your response must be concise. 0.22. What is the ratio of the HFC emissions (in thousand metric tons of CO2 equivalent) of 2008 in Italy to that in Japan?
Provide a succinct answer. 0.23. What is the ratio of the HFC emissions (in thousand metric tons of CO2 equivalent) of 1990 in Italy to that in Korea (Democratic)?
Your response must be concise. 9861. What is the ratio of the HFC emissions (in thousand metric tons of CO2 equivalent) of 2000 in Italy to that in Korea (Democratic)?
Your answer should be compact. 4.03. What is the ratio of the HFC emissions (in thousand metric tons of CO2 equivalent) in 2005 in Italy to that in Korea (Democratic)?
Make the answer very short. 3.27. What is the ratio of the HFC emissions (in thousand metric tons of CO2 equivalent) in 2008 in Italy to that in Korea (Democratic)?
Keep it short and to the point. 3.23. What is the ratio of the HFC emissions (in thousand metric tons of CO2 equivalent) in 1990 in Italy to that in Korea (Republic)?
Provide a short and direct response. 1.04. What is the ratio of the HFC emissions (in thousand metric tons of CO2 equivalent) of 2000 in Italy to that in Korea (Republic)?
Offer a terse response. 0.85. What is the ratio of the HFC emissions (in thousand metric tons of CO2 equivalent) of 2005 in Italy to that in Korea (Republic)?
Offer a very short reply. 1.85. What is the ratio of the HFC emissions (in thousand metric tons of CO2 equivalent) of 2008 in Italy to that in Korea (Republic)?
Make the answer very short. 4.75. What is the ratio of the HFC emissions (in thousand metric tons of CO2 equivalent) of 1990 in Japan to that in Korea (Democratic)?
Provide a short and direct response. 4.58e+04. What is the ratio of the HFC emissions (in thousand metric tons of CO2 equivalent) of 2000 in Japan to that in Korea (Democratic)?
Provide a short and direct response. 19.4. What is the ratio of the HFC emissions (in thousand metric tons of CO2 equivalent) in 2005 in Japan to that in Korea (Democratic)?
Your answer should be very brief. 14.63. What is the ratio of the HFC emissions (in thousand metric tons of CO2 equivalent) in 2008 in Japan to that in Korea (Democratic)?
Make the answer very short. 14.31. What is the ratio of the HFC emissions (in thousand metric tons of CO2 equivalent) of 1990 in Japan to that in Korea (Republic)?
Your response must be concise. 4.81. What is the ratio of the HFC emissions (in thousand metric tons of CO2 equivalent) of 2000 in Japan to that in Korea (Republic)?
Your answer should be compact. 4.08. What is the ratio of the HFC emissions (in thousand metric tons of CO2 equivalent) of 2005 in Japan to that in Korea (Republic)?
Offer a very short reply. 8.26. What is the ratio of the HFC emissions (in thousand metric tons of CO2 equivalent) of 2008 in Japan to that in Korea (Republic)?
Provide a short and direct response. 21.05. What is the ratio of the HFC emissions (in thousand metric tons of CO2 equivalent) in 1990 in Korea (Democratic) to that in Korea (Republic)?
Offer a very short reply. 0. What is the ratio of the HFC emissions (in thousand metric tons of CO2 equivalent) in 2000 in Korea (Democratic) to that in Korea (Republic)?
Provide a succinct answer. 0.21. What is the ratio of the HFC emissions (in thousand metric tons of CO2 equivalent) of 2005 in Korea (Democratic) to that in Korea (Republic)?
Give a very brief answer. 0.56. What is the ratio of the HFC emissions (in thousand metric tons of CO2 equivalent) of 2008 in Korea (Democratic) to that in Korea (Republic)?
Ensure brevity in your answer.  1.47. What is the difference between the highest and the second highest HFC emissions (in thousand metric tons of CO2 equivalent) of 1990?
Ensure brevity in your answer.  7182.1. What is the difference between the highest and the second highest HFC emissions (in thousand metric tons of CO2 equivalent) of 2000?
Ensure brevity in your answer.  2.58e+04. What is the difference between the highest and the second highest HFC emissions (in thousand metric tons of CO2 equivalent) of 2005?
Your answer should be compact. 3.17e+04. What is the difference between the highest and the second highest HFC emissions (in thousand metric tons of CO2 equivalent) of 2008?
Provide a succinct answer. 4.09e+04. What is the difference between the highest and the lowest HFC emissions (in thousand metric tons of CO2 equivalent) in 1990?
Provide a succinct answer. 9154.1. What is the difference between the highest and the lowest HFC emissions (in thousand metric tons of CO2 equivalent) in 2000?
Provide a short and direct response. 3.37e+04. What is the difference between the highest and the lowest HFC emissions (in thousand metric tons of CO2 equivalent) of 2005?
Keep it short and to the point. 3.99e+04. What is the difference between the highest and the lowest HFC emissions (in thousand metric tons of CO2 equivalent) of 2008?
Your answer should be very brief. 5.17e+04. 